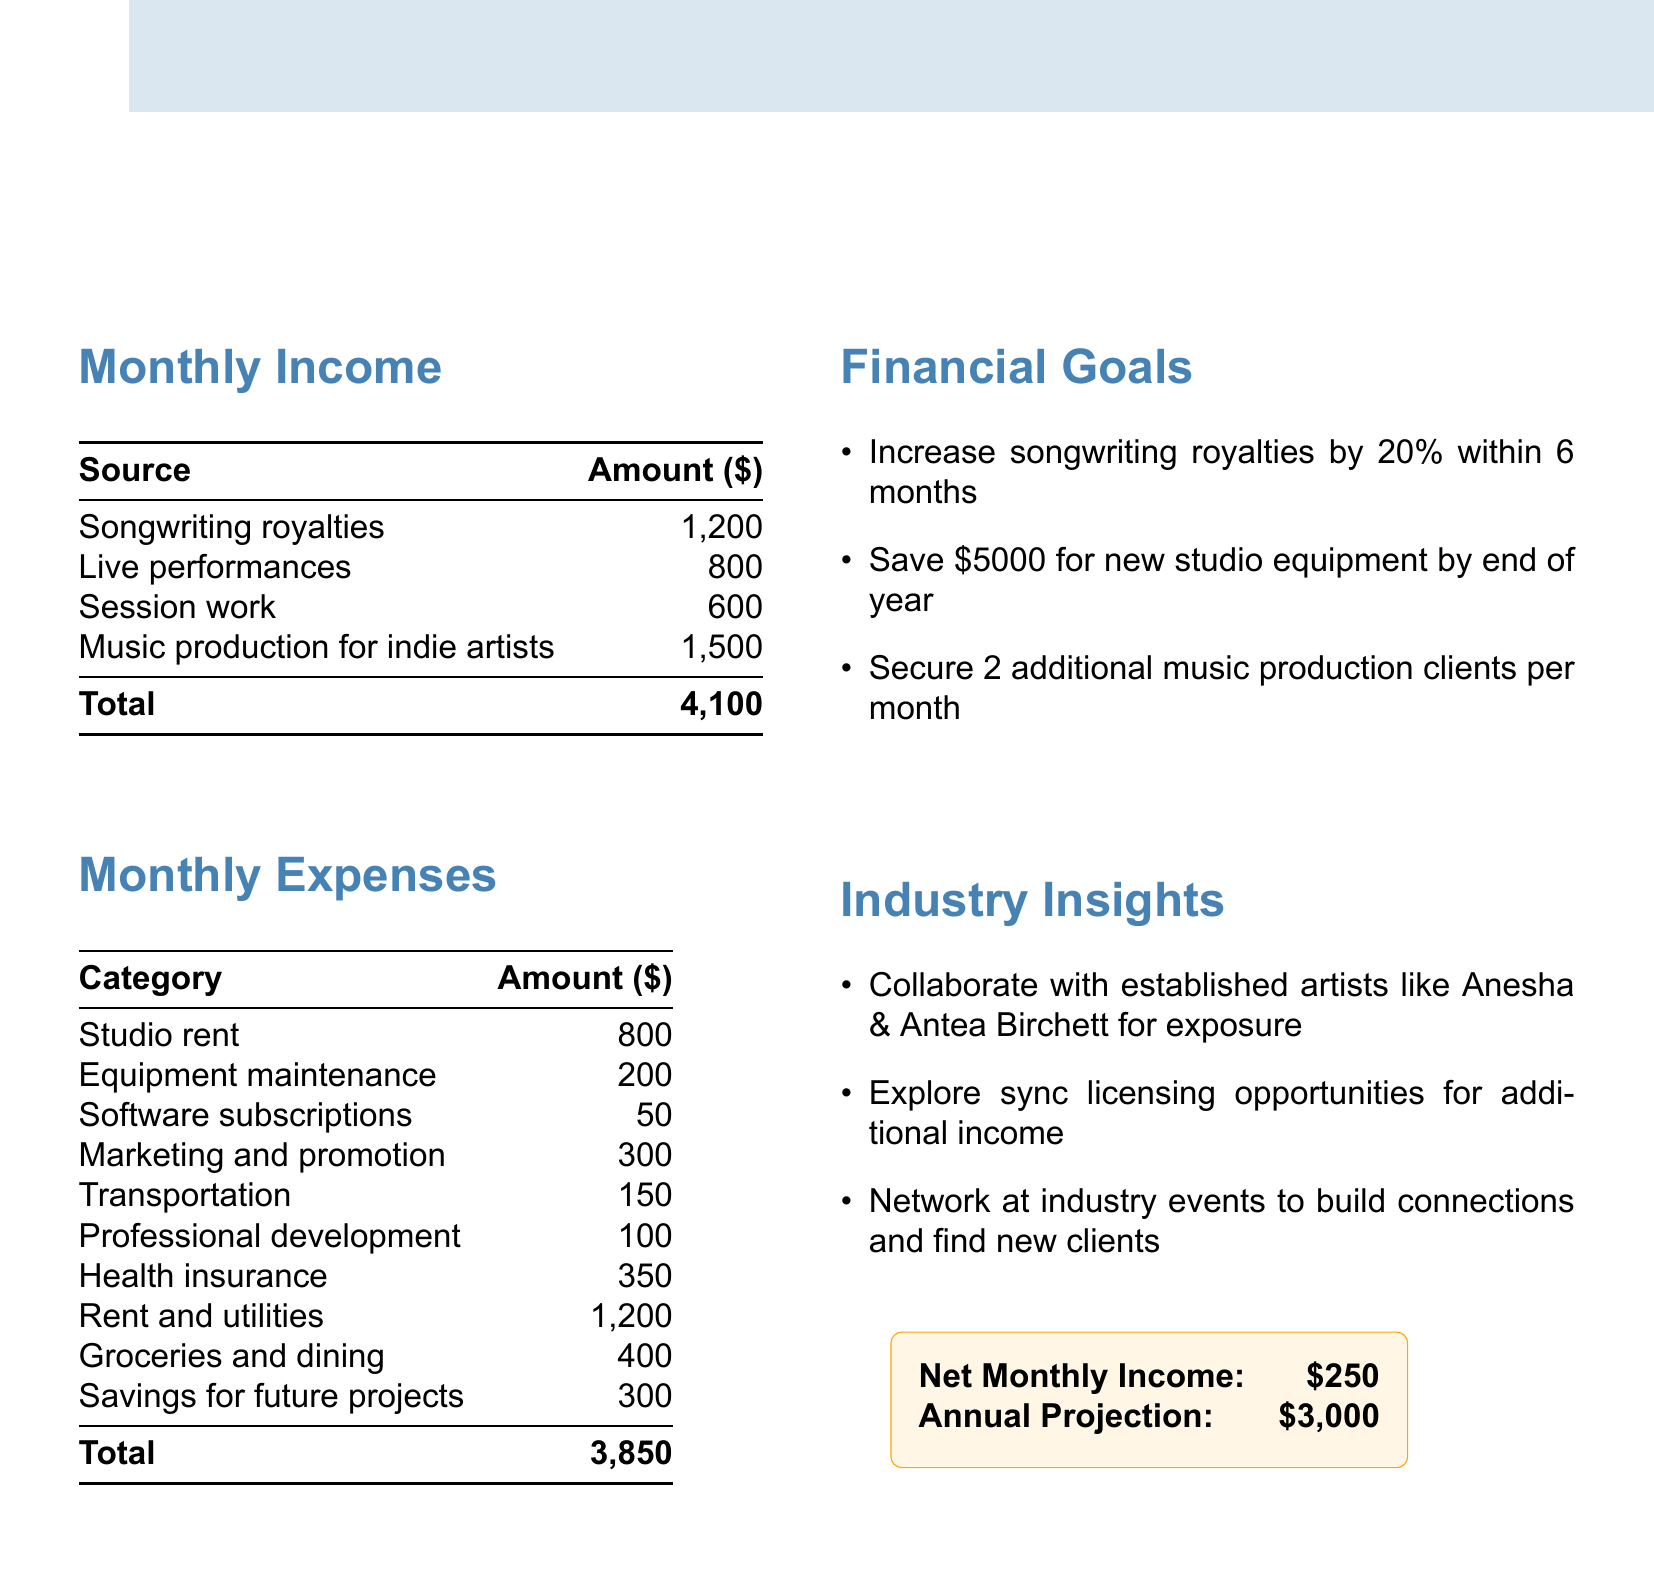what is the total monthly income? The total monthly income is the sum of all income sources listed in the document, which amounts to $1200 + $800 + $600 + $1500 = $4100.
Answer: $4100 what is the highest expense category? The highest expense category is identified from the list, which is Rent and utilities at $1200.
Answer: Rent and utilities what is the net monthly income? The net monthly income is calculated by subtracting total expenses from total income, which is $4100 - $3850 = $250.
Answer: $250 how much is allocated for marketing and promotion? The amount allocated for marketing and promotion is specified in the monthly expenses section, which is $300.
Answer: $300 what percentage increase in royalties is targeted? The targeted increase in songwriting royalties is noted as 20%.
Answer: 20% how many additional music production clients are targeted per month? The document states the goal to secure 2 additional music production clients per month.
Answer: 2 what is the total amount set aside for savings? The total amount set aside for savings for future projects is indicated as $300.
Answer: $300 which artists are recommended for collaboration? The document suggests collaborating with Anesha and Antea Birchett for exposure.
Answer: Anesha & Antea Birchett what is the amount budgeted for health insurance? The budgeted amount for health insurance is listed under monthly expenses as $350.
Answer: $350 